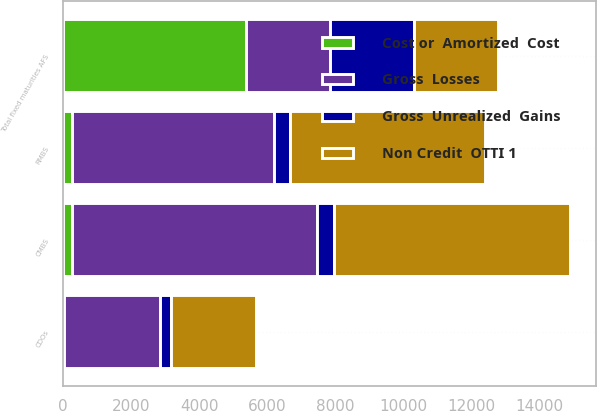<chart> <loc_0><loc_0><loc_500><loc_500><stacked_bar_chart><ecel><fcel>CDOs<fcel>CMBS<fcel>RMBS<fcel>Total fixed maturities AFS<nl><fcel>Gross  Losses<fcel>2819<fcel>7192<fcel>5961<fcel>2479<nl><fcel>Cost or  Amortized  Cost<fcel>16<fcel>271<fcel>252<fcel>5374<nl><fcel>Gross  Unrealized  Gains<fcel>348<fcel>512<fcel>456<fcel>2471<nl><fcel>Non Credit  OTTI 1<fcel>2487<fcel>6951<fcel>5757<fcel>2479<nl></chart> 